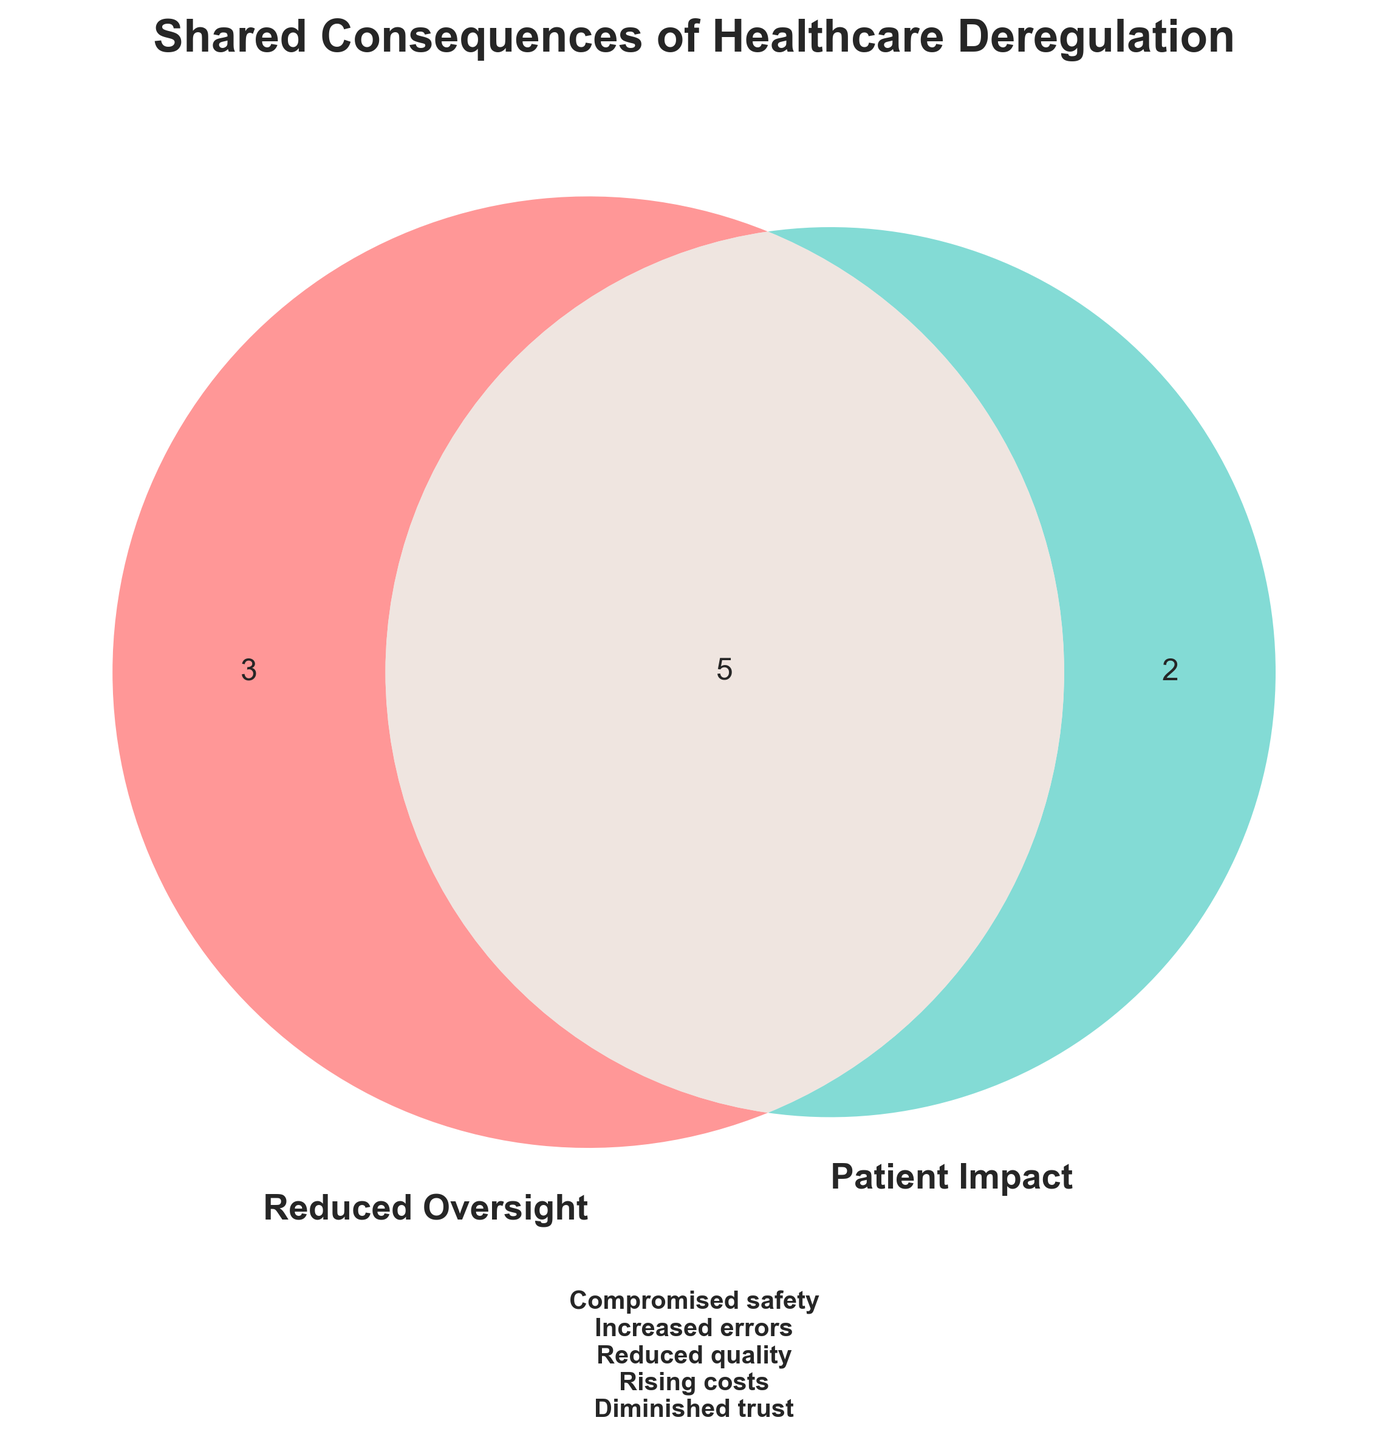What is the title of the figure? The title is displayed prominently at the top of the figure. It reads "Shared Consequences of Healthcare Deregulation".
Answer: Shared Consequences of Healthcare Deregulation How many subsets are present in the Venn diagram? By looking at the Venn diagram, we can see there are three areas: the part unique to "Reduced Oversight", the part unique to "Patient Impact", and the intersection.
Answer: Three What are some examples of consequences that fall into the intersection between "Reduced Oversight" and "Patient Impact"? The text in the middle, where the two circles overlap, lists the shared consequences. These include "Compromised safety standards", "Increased medical errors", "Reduced quality of care", "Rising healthcare costs", and "Diminished patient trust".
Answer: Compromised safety standards, Increased medical errors, Reduced quality of care, Rising healthcare costs, Diminished patient trust Which set includes "Longer wait times"? The consequence "Longer wait times" is listed under "Patient Impact".
Answer: Patient Impact How does the diagram visually differentiate between the two sets? The Venn diagram uses different colors for each set: one circle is red (indicating "Reduced Oversight") and the other is cyan (indicating "Patient Impact"). There is also text in each circle specifying which set it represents.
Answer: Different colors (red and cyan) What is the color of the circle labeled "Reduced Oversight"? The circle labeled "Reduced Oversight" is colored red.
Answer: Red Which set includes "Weakened malpractice laws"? By looking at the left circle, labeled "Reduced Oversight", we can see that "Weakened malpractice laws" is listed under this set.
Answer: Reduced Oversight Are there more consequences listed uniquely under "Reduced Oversight" or "Patient Impact"? Both the left and right circles each list five consequences, meaning there are an equal number of consequences under "Reduced Oversight" and "Patient Impact".
Answer: Equal number Explain why "Reduced quality of care" is in the intersection. The intersection represents shared consequences of both "Reduced Oversight" and "Patient Impact". "Reduced quality of care" is placed here because it is a consequence that stems from both reduced oversight in healthcare and its impact on patients.
Answer: It is a shared consequence What is the relationship between "Increased medical errors" and healthcare deregulation according to the Venn diagram? "Increased medical errors" is found in the intersection of the Venn diagram, indicating it is a consequence that results from both "Reduced Oversight" and "Patient Impact" due to healthcare deregulation.
Answer: It is a shared consequence 